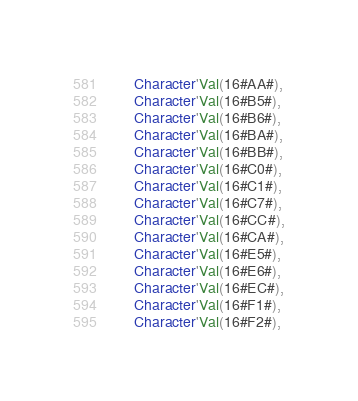<code> <loc_0><loc_0><loc_500><loc_500><_Ada_>      Character'Val(16#AA#),
      Character'Val(16#B5#),
      Character'Val(16#B6#),
      Character'Val(16#BA#),
      Character'Val(16#BB#),
      Character'Val(16#C0#),
      Character'Val(16#C1#),
      Character'Val(16#C7#),
      Character'Val(16#CC#),
      Character'Val(16#CA#),
      Character'Val(16#E5#),
      Character'Val(16#E6#),
      Character'Val(16#EC#),
      Character'Val(16#F1#),
      Character'Val(16#F2#),</code> 